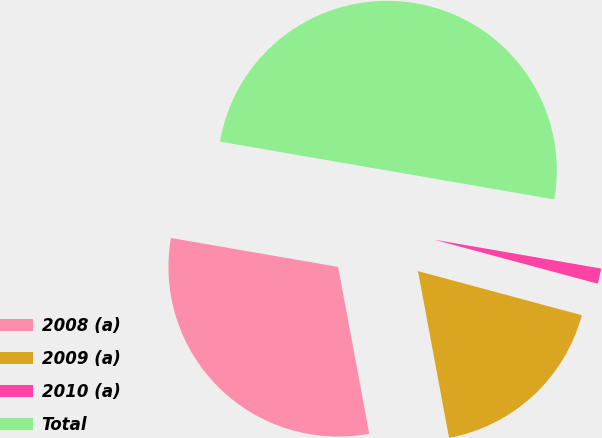Convert chart. <chart><loc_0><loc_0><loc_500><loc_500><pie_chart><fcel>2008 (a)<fcel>2009 (a)<fcel>2010 (a)<fcel>Total<nl><fcel>30.66%<fcel>17.88%<fcel>1.46%<fcel>50.0%<nl></chart> 